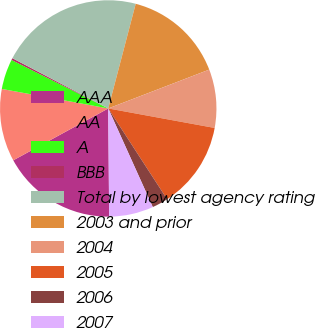Convert chart. <chart><loc_0><loc_0><loc_500><loc_500><pie_chart><fcel>AAA<fcel>AA<fcel>A<fcel>BBB<fcel>Total by lowest agency rating<fcel>2003 and prior<fcel>2004<fcel>2005<fcel>2006<fcel>2007<nl><fcel>17.18%<fcel>10.84%<fcel>4.51%<fcel>0.29%<fcel>21.4%<fcel>15.07%<fcel>8.73%<fcel>12.96%<fcel>2.4%<fcel>6.62%<nl></chart> 